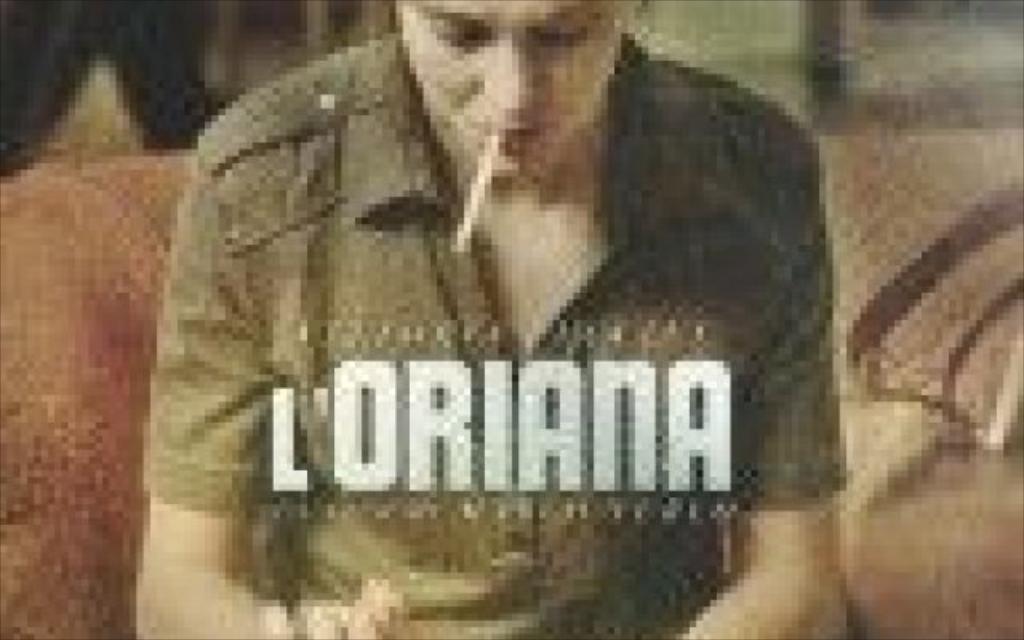In one or two sentences, can you explain what this image depicts? This is a blurred image. In this image we can see a person with a cigarette in the mouth. He is sitting on the sofa. And something is written on the image. 